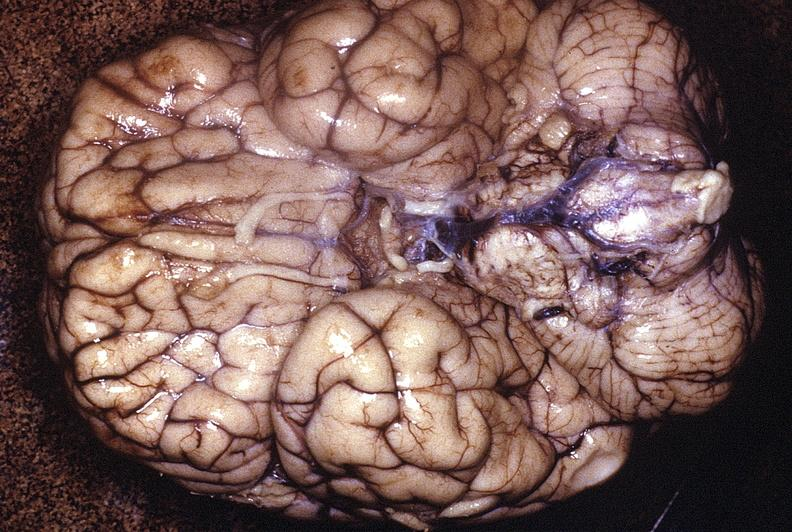does lesion in dome of uterus show normal brain?
Answer the question using a single word or phrase. No 